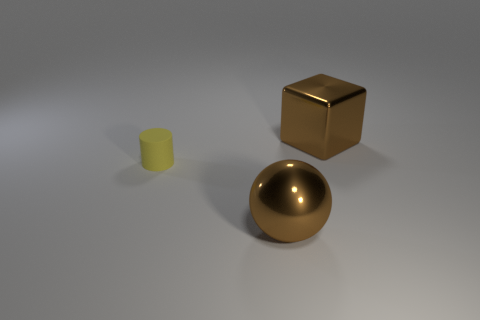Is there any other thing of the same color as the cylinder?
Give a very brief answer. No. Is the number of brown metallic cubes in front of the tiny cylinder less than the number of brown cubes?
Offer a terse response. Yes. What number of brown metal cylinders are the same size as the sphere?
Keep it short and to the point. 0. There is a metal object that is the same color as the large cube; what is its shape?
Keep it short and to the point. Sphere. There is a shiny thing behind the brown metal object in front of the thing behind the yellow cylinder; what shape is it?
Keep it short and to the point. Cube. There is a big metal ball in front of the yellow rubber cylinder; what color is it?
Your answer should be compact. Brown. How many things are large brown metallic things that are in front of the yellow cylinder or big brown blocks that are behind the yellow cylinder?
Give a very brief answer. 2. What number of other tiny yellow rubber objects have the same shape as the small matte thing?
Offer a very short reply. 0. The block that is the same size as the sphere is what color?
Keep it short and to the point. Brown. There is a large object that is left of the large object that is behind the metallic object in front of the small matte object; what is its color?
Ensure brevity in your answer.  Brown. 